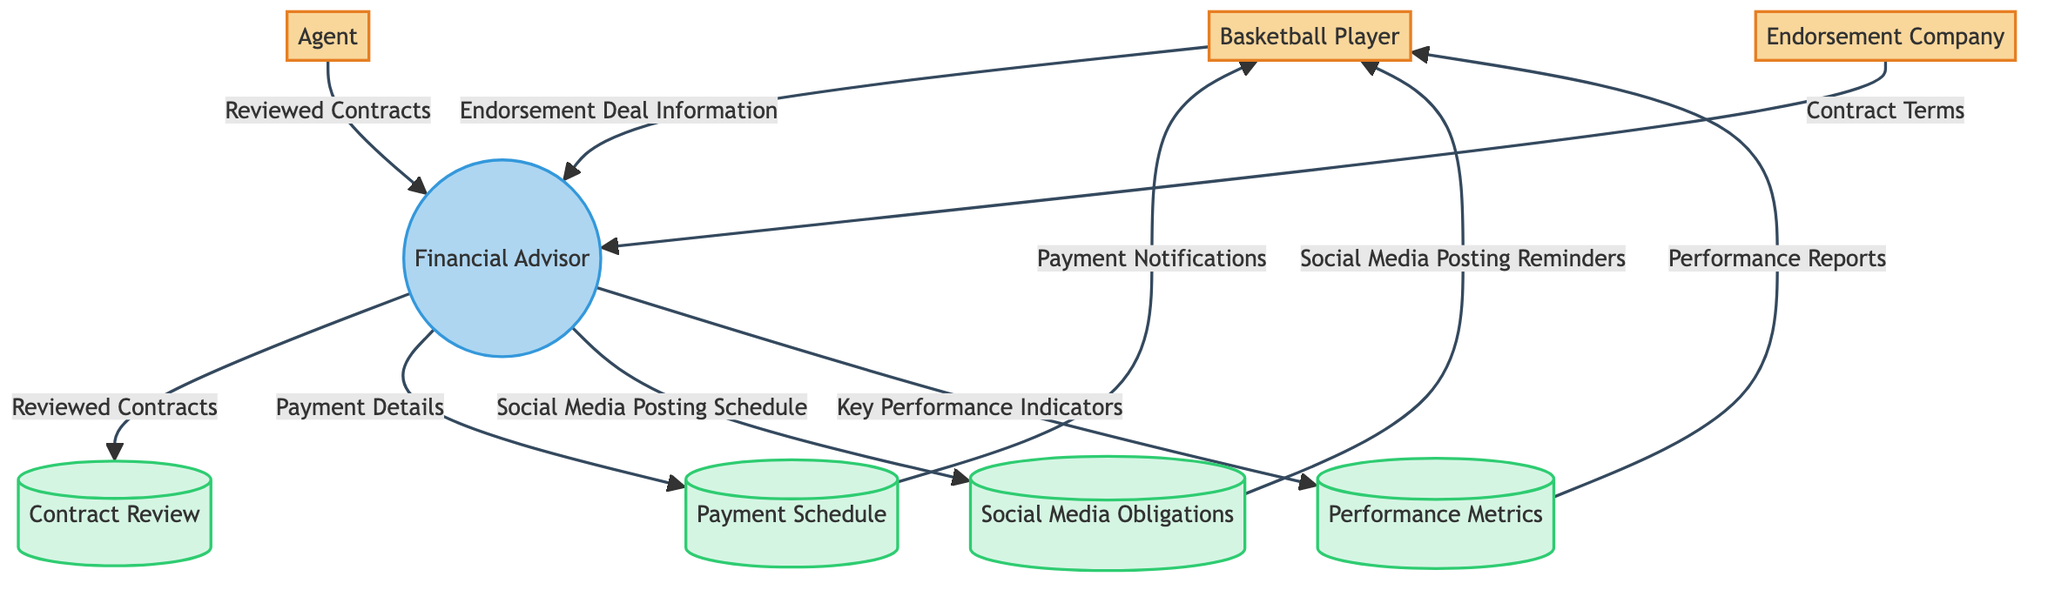What are the two external entities interacting with the Financial Advisor? In the diagram, the two external entities that interact with the Financial Advisor are the Agent and the Endorsement Company. The arrows connecting them to the Financial Advisor indicate their involvement.
Answer: Agent and Endorsement Company How many data stores are present in the diagram? The diagram contains four data stores: Contract Review, Payment Schedule, Social Media Obligations, and Performance Metrics. Each of these stores is depicted as a separate component in the structure.
Answer: Four What type of information does the Basketball Player provide to the Financial Advisor? The Basketball Player provides 'Endorsement Deal Information' to the Financial Advisor, as indicated by the arrow leading from the Basketball Player to the Financial Advisor.
Answer: Endorsement Deal Information Which entity receives the Performance Reports? The Performance Reports are sent from the Performance Metrics data store to the Basketball Player, as shown by the arrow going from Performance Metrics to the Basketball Player.
Answer: Basketball Player What is the flow of social media obligations from the Financial Advisor? The Financial Advisor sends a 'Social Media Posting Schedule' to the Social Media Obligations data store. This means that the schedule flows from the advisor to the obligations store.
Answer: Social Media Posting Schedule Explain the flow from the Endorsement Company to the Financial Advisor. The Endorsement Company sends 'Contract Terms' to the Financial Advisor. This indicates that the Financial Advisor is reviewing or managing these terms as part of the endorsement deal process.
Answer: Contract Terms What kind of payment-related details does the Financial Advisor manage? The Financial Advisor manages 'Payment Details', which are directed to the Payment Schedule data store, indicating how payment schedules are organized and maintained.
Answer: Payment Details Who is responsible for sending Social Media Posting Reminders? The Social Media Posting Reminders are sent from the Social Media Obligations data store to the Basketball Player, showing that it is the player's responsibility to adhere to these reminders.
Answer: Basketball Player In total, how many data flows originate from the Financial Advisor? There are five data flows that originate from the Financial Advisor, including Reviewed Contracts, Payment Details, Social Media Posting Schedule, and Key Performance Indicators.
Answer: Five 